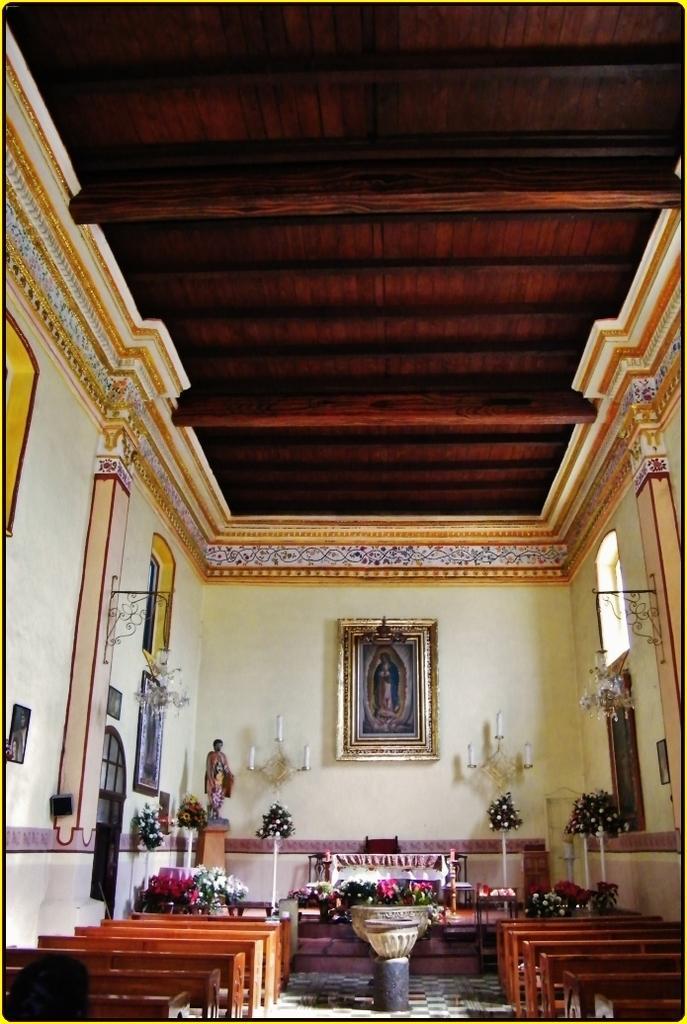Can you describe this image briefly? In this image we can see inside view of a building. In the foreground of the image we can see a group of chairs, vase placed on the ground. In the center of the image we can see some flowers, table and chair, On the left side of the image we can see a statue, speaker on the wall. In the background, we can see candles on stands, photo frames on the wall, a group of lights and the roof. 